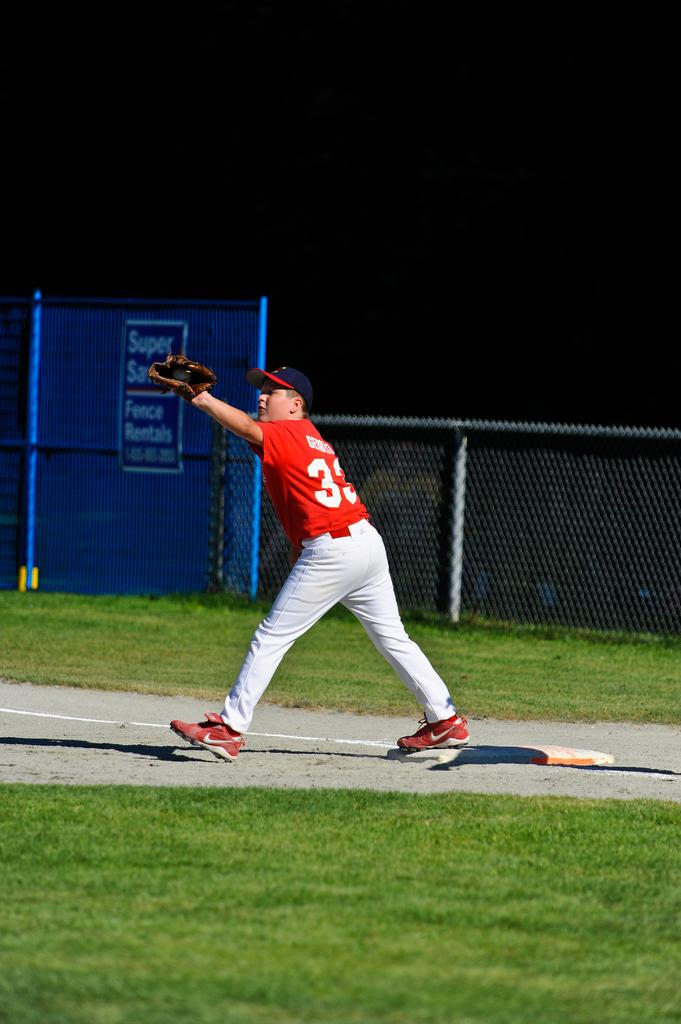Provide a one-sentence caption for the provided image. Baseball player number 33 caught the ball in front of the Fence Rentals sign. 